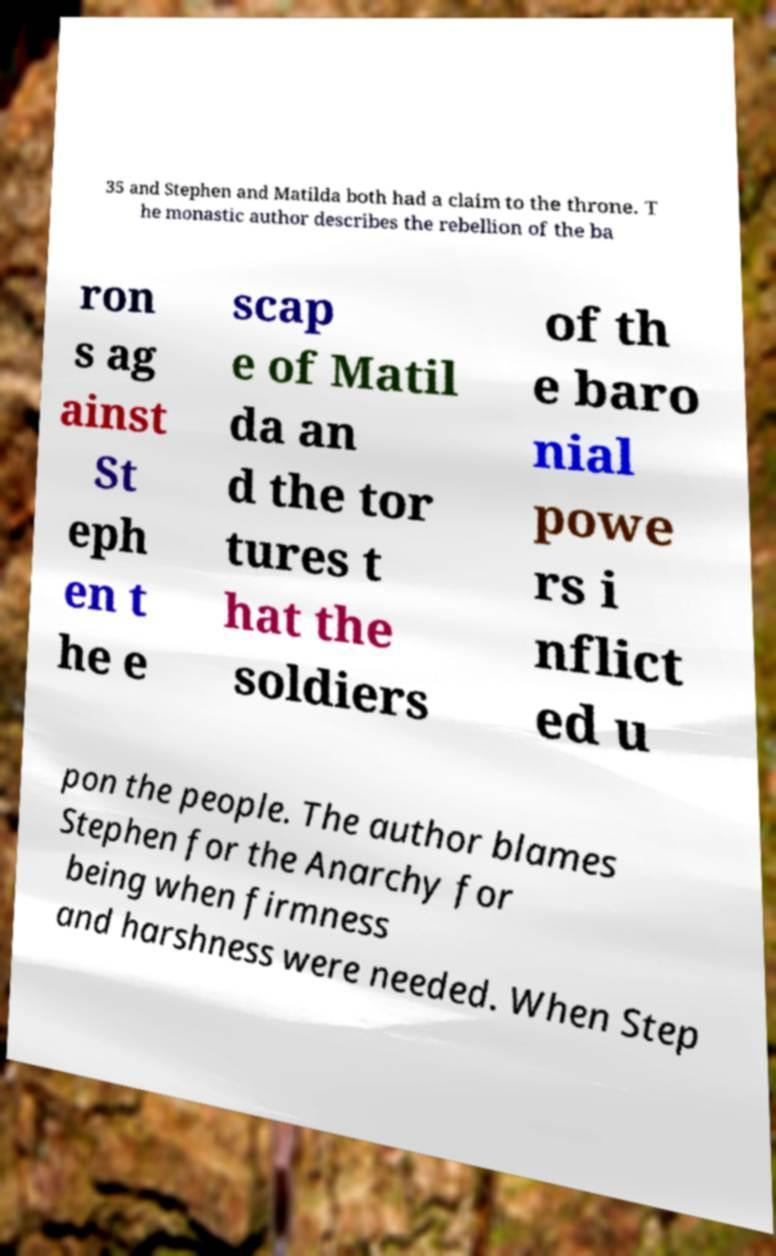Please read and relay the text visible in this image. What does it say? 35 and Stephen and Matilda both had a claim to the throne. T he monastic author describes the rebellion of the ba ron s ag ainst St eph en t he e scap e of Matil da an d the tor tures t hat the soldiers of th e baro nial powe rs i nflict ed u pon the people. The author blames Stephen for the Anarchy for being when firmness and harshness were needed. When Step 